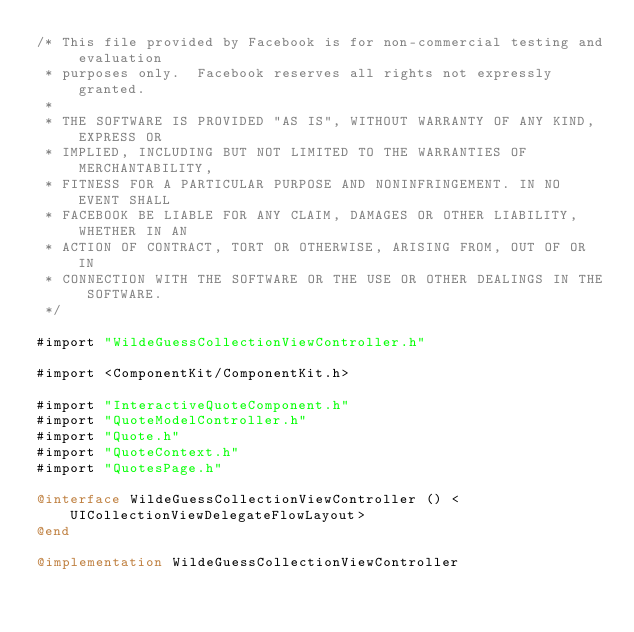Convert code to text. <code><loc_0><loc_0><loc_500><loc_500><_ObjectiveC_>/* This file provided by Facebook is for non-commercial testing and evaluation
 * purposes only.  Facebook reserves all rights not expressly granted.
 *
 * THE SOFTWARE IS PROVIDED "AS IS", WITHOUT WARRANTY OF ANY KIND, EXPRESS OR
 * IMPLIED, INCLUDING BUT NOT LIMITED TO THE WARRANTIES OF MERCHANTABILITY,
 * FITNESS FOR A PARTICULAR PURPOSE AND NONINFRINGEMENT. IN NO EVENT SHALL
 * FACEBOOK BE LIABLE FOR ANY CLAIM, DAMAGES OR OTHER LIABILITY, WHETHER IN AN
 * ACTION OF CONTRACT, TORT OR OTHERWISE, ARISING FROM, OUT OF OR IN
 * CONNECTION WITH THE SOFTWARE OR THE USE OR OTHER DEALINGS IN THE SOFTWARE.
 */

#import "WildeGuessCollectionViewController.h"

#import <ComponentKit/ComponentKit.h>

#import "InteractiveQuoteComponent.h"
#import "QuoteModelController.h"
#import "Quote.h"
#import "QuoteContext.h"
#import "QuotesPage.h"

@interface WildeGuessCollectionViewController () <UICollectionViewDelegateFlowLayout>
@end

@implementation WildeGuessCollectionViewController</code> 